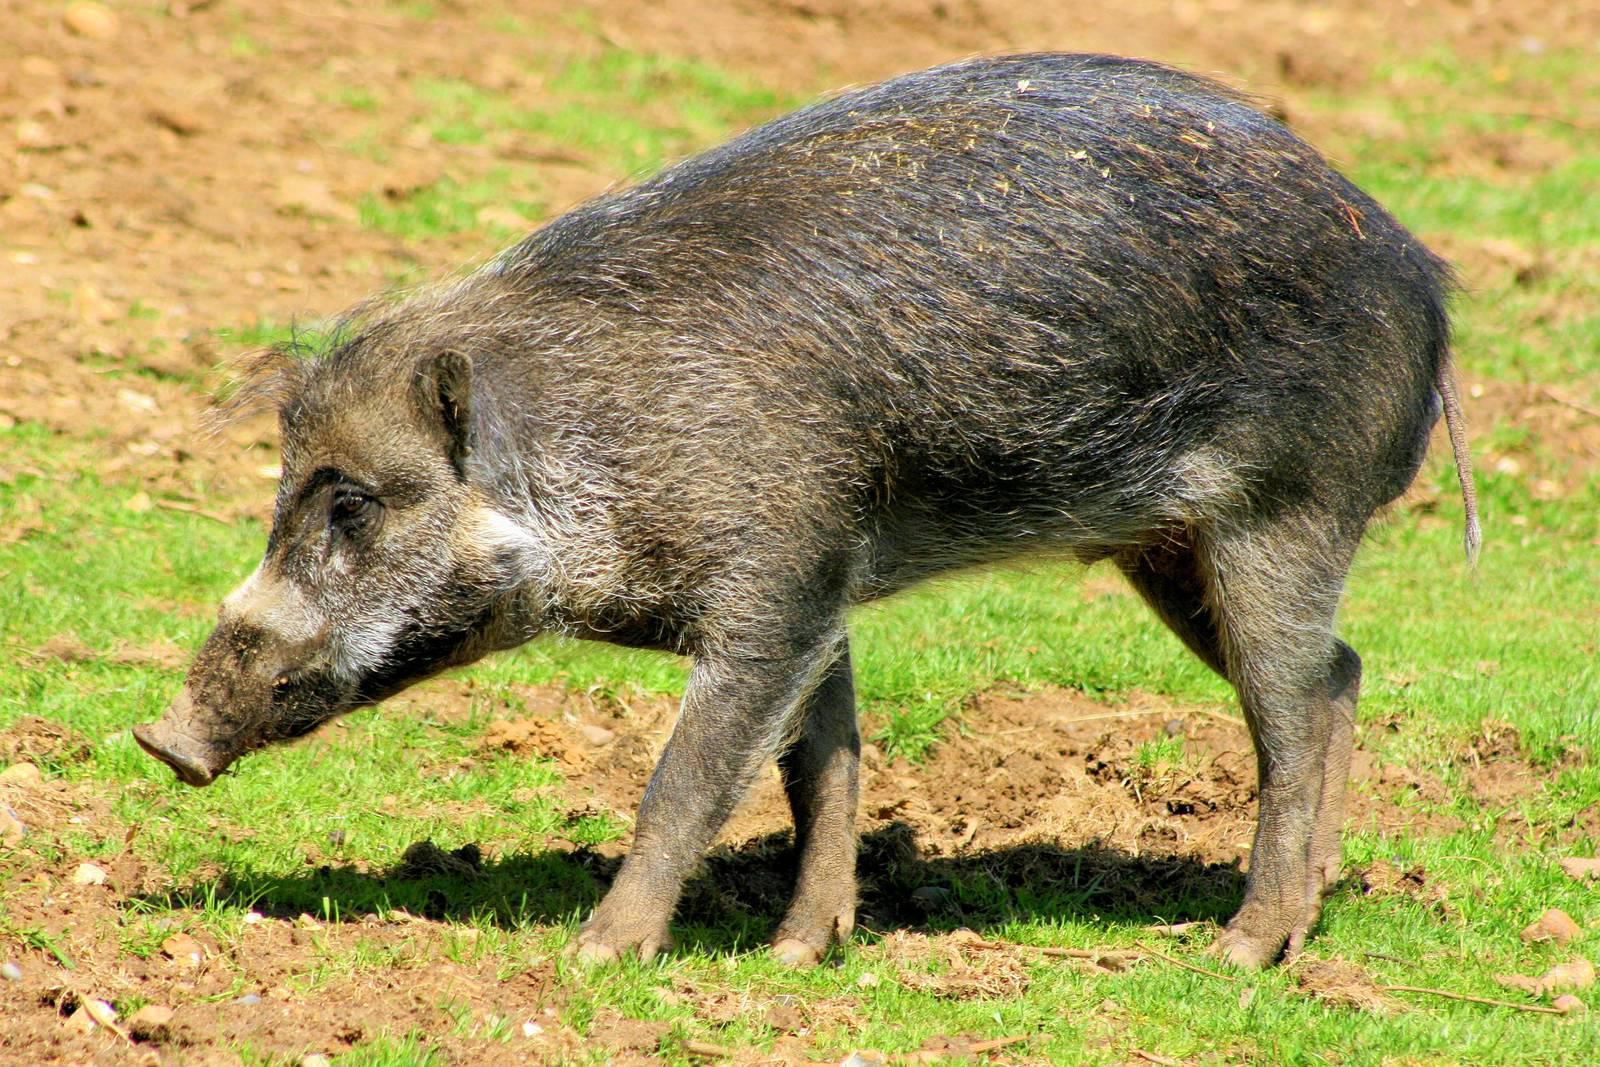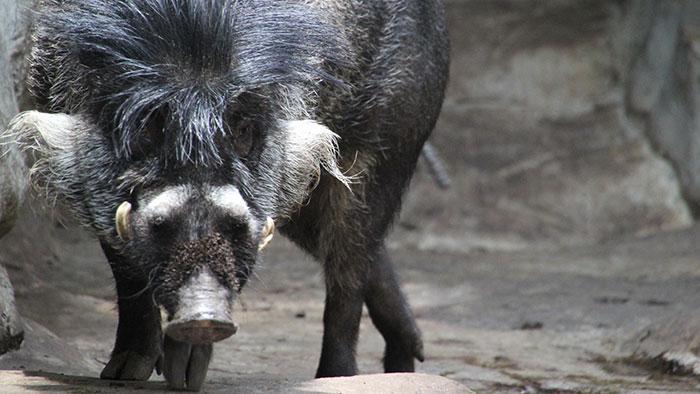The first image is the image on the left, the second image is the image on the right. For the images displayed, is the sentence "At least one pig has its snout on the ground." factually correct? Answer yes or no. No. The first image is the image on the left, the second image is the image on the right. Analyze the images presented: Is the assertion "There is one mammal facing to the side, and one mammal facing the camera." valid? Answer yes or no. Yes. 